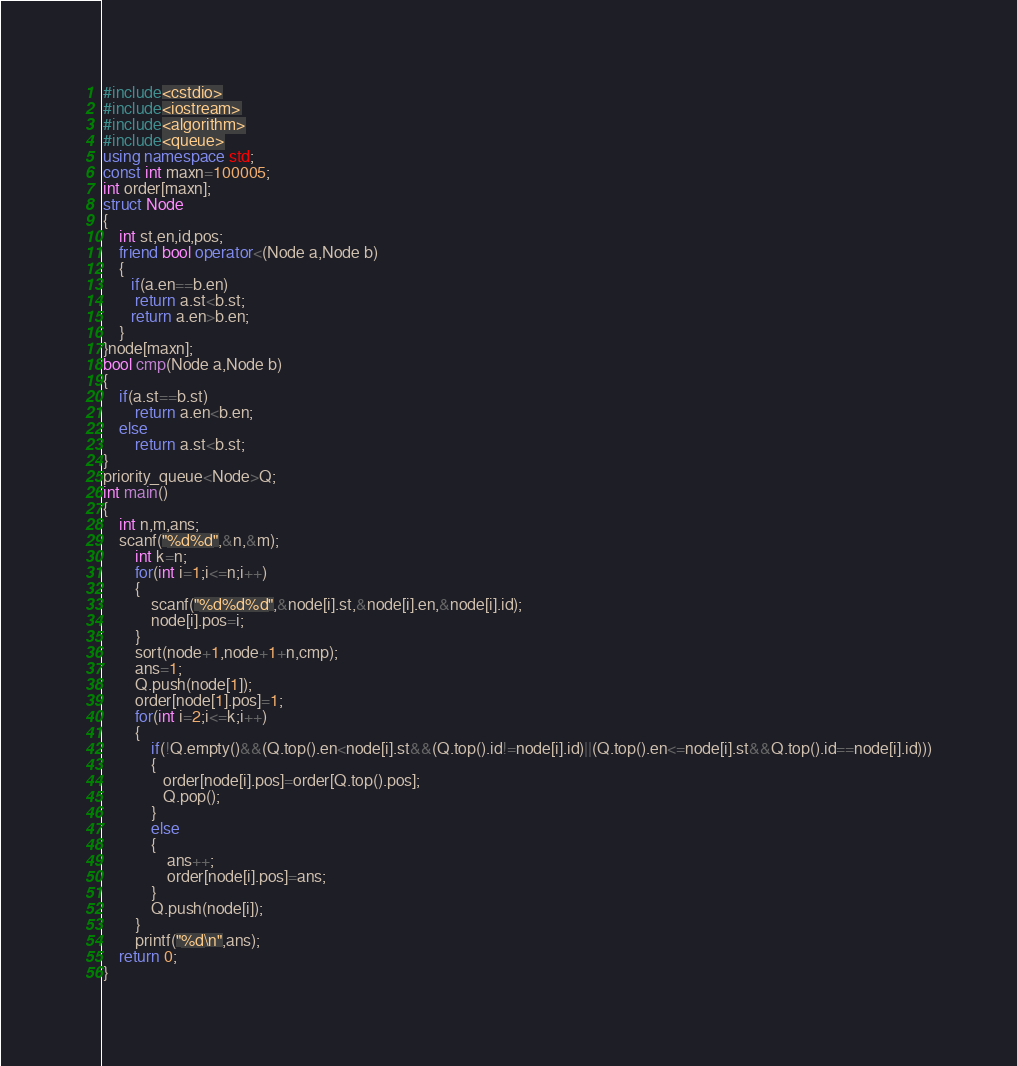Convert code to text. <code><loc_0><loc_0><loc_500><loc_500><_C++_>#include<cstdio>
#include<iostream>
#include<algorithm>
#include<queue>
using namespace std;
const int maxn=100005;
int order[maxn];
struct Node
{
    int st,en,id,pos;
    friend bool operator<(Node a,Node b)
    {
       if(a.en==b.en)
        return a.st<b.st;
       return a.en>b.en;
    }
}node[maxn];
bool cmp(Node a,Node b)
{
    if(a.st==b.st)
        return a.en<b.en;
    else
        return a.st<b.st;
}
priority_queue<Node>Q;
int main()
{
    int n,m,ans;
    scanf("%d%d",&n,&m);
        int k=n;
        for(int i=1;i<=n;i++)
        {
            scanf("%d%d%d",&node[i].st,&node[i].en,&node[i].id);
            node[i].pos=i;
        }
        sort(node+1,node+1+n,cmp);
        ans=1;
        Q.push(node[1]);
        order[node[1].pos]=1;
        for(int i=2;i<=k;i++)
        {
            if(!Q.empty()&&(Q.top().en<node[i].st&&(Q.top().id!=node[i].id)||(Q.top().en<=node[i].st&&Q.top().id==node[i].id)))
            {
               order[node[i].pos]=order[Q.top().pos];
               Q.pop();
            }
            else
            {
                ans++;
                order[node[i].pos]=ans;
            }
            Q.push(node[i]);
        }
        printf("%d\n",ans);
    return 0;
}</code> 